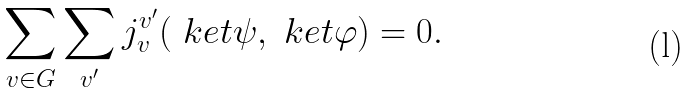Convert formula to latex. <formula><loc_0><loc_0><loc_500><loc_500>\sum _ { v \in G } \sum _ { v ^ { \prime } } j _ { v } ^ { v ^ { \prime } } ( \ k e t { \psi } , \ k e t { \varphi } ) = 0 .</formula> 